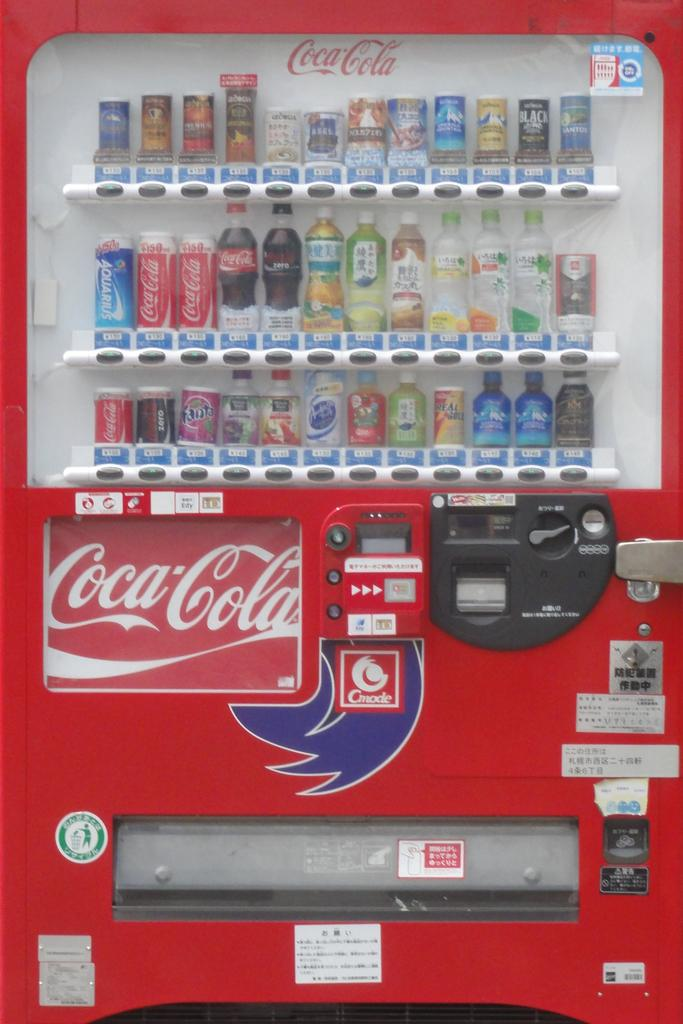Provide a one-sentence caption for the provided image. The Coca cola vending machine has a large variety of sodas and juices to choose from. 